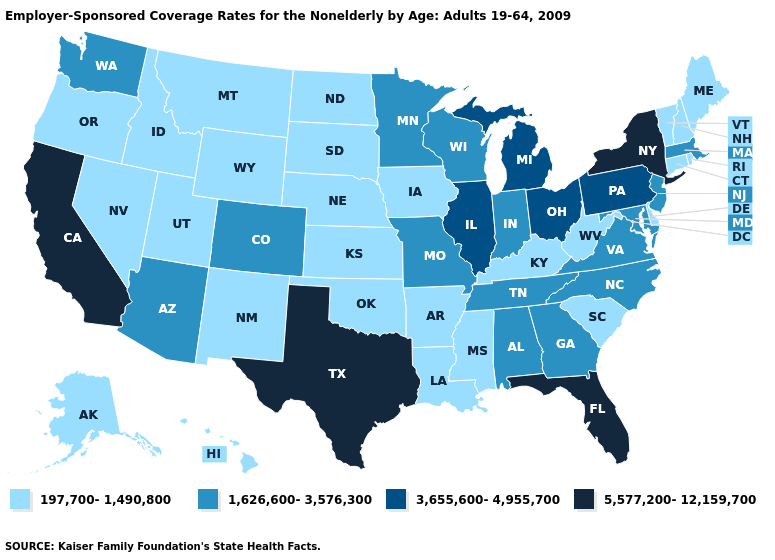Name the states that have a value in the range 3,655,600-4,955,700?
Concise answer only. Illinois, Michigan, Ohio, Pennsylvania. Among the states that border Connecticut , which have the highest value?
Write a very short answer. New York. Name the states that have a value in the range 5,577,200-12,159,700?
Write a very short answer. California, Florida, New York, Texas. What is the highest value in the USA?
Write a very short answer. 5,577,200-12,159,700. Does the map have missing data?
Answer briefly. No. Does Illinois have a higher value than North Dakota?
Quick response, please. Yes. What is the highest value in states that border Wisconsin?
Be succinct. 3,655,600-4,955,700. Name the states that have a value in the range 5,577,200-12,159,700?
Short answer required. California, Florida, New York, Texas. Does the map have missing data?
Write a very short answer. No. Name the states that have a value in the range 197,700-1,490,800?
Concise answer only. Alaska, Arkansas, Connecticut, Delaware, Hawaii, Idaho, Iowa, Kansas, Kentucky, Louisiana, Maine, Mississippi, Montana, Nebraska, Nevada, New Hampshire, New Mexico, North Dakota, Oklahoma, Oregon, Rhode Island, South Carolina, South Dakota, Utah, Vermont, West Virginia, Wyoming. Name the states that have a value in the range 197,700-1,490,800?
Answer briefly. Alaska, Arkansas, Connecticut, Delaware, Hawaii, Idaho, Iowa, Kansas, Kentucky, Louisiana, Maine, Mississippi, Montana, Nebraska, Nevada, New Hampshire, New Mexico, North Dakota, Oklahoma, Oregon, Rhode Island, South Carolina, South Dakota, Utah, Vermont, West Virginia, Wyoming. What is the lowest value in the USA?
Answer briefly. 197,700-1,490,800. Name the states that have a value in the range 197,700-1,490,800?
Concise answer only. Alaska, Arkansas, Connecticut, Delaware, Hawaii, Idaho, Iowa, Kansas, Kentucky, Louisiana, Maine, Mississippi, Montana, Nebraska, Nevada, New Hampshire, New Mexico, North Dakota, Oklahoma, Oregon, Rhode Island, South Carolina, South Dakota, Utah, Vermont, West Virginia, Wyoming. Does the first symbol in the legend represent the smallest category?
Keep it brief. Yes. What is the lowest value in the West?
Quick response, please. 197,700-1,490,800. 